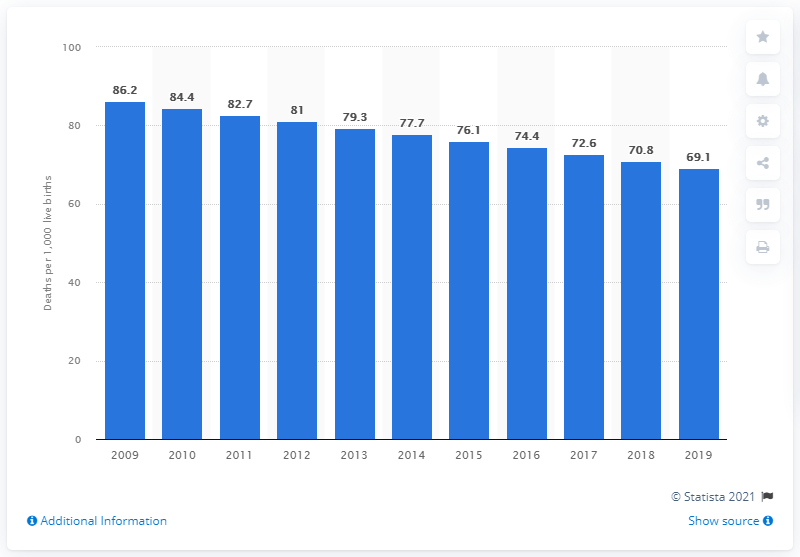Highlight a few significant elements in this photo. The infant mortality rate in Chad in 2019 was 69.1 deaths per 1,000 live births. 